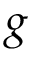Convert formula to latex. <formula><loc_0><loc_0><loc_500><loc_500>g</formula> 